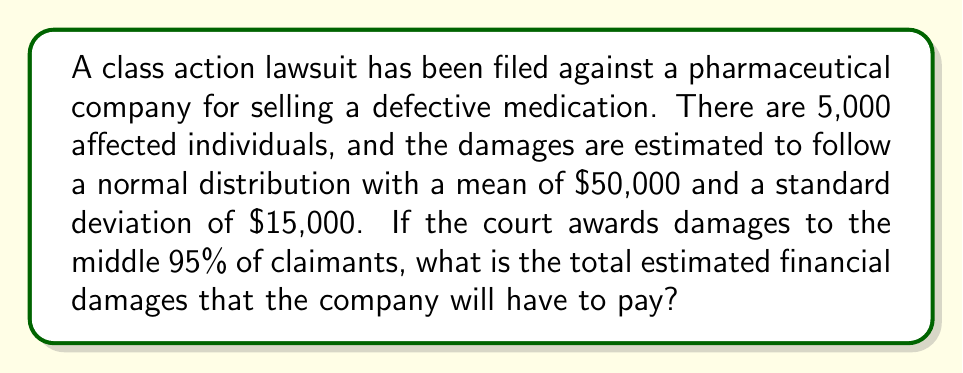Show me your answer to this math problem. To solve this problem, we'll follow these steps:

1. Identify the relevant statistical concepts:
   - Normal distribution
   - Z-score
   - Confidence interval

2. Find the z-scores for the middle 95% of the distribution:
   The middle 95% corresponds to a 95% confidence interval, which has z-scores of ±1.96.

3. Calculate the lower and upper bounds of the awards:
   Lower bound: $\mu - 1.96\sigma = 50000 - 1.96(15000) = 20600$
   Upper bound: $\mu + 1.96\sigma = 50000 + 1.96(15000) = 79400$

4. Calculate the number of claimants within this range:
   95% of 5,000 = 0.95 * 5000 = 4,750 claimants

5. Calculate the total damages:
   Total damages = Number of claimants * Average award
   Average award = $(\text{Lower bound} + \text{Upper bound}) / 2$
   
   $$\text{Average award} = \frac{20600 + 79400}{2} = 50000$$
   
   $$\text{Total damages} = 4750 * 50000 = 237,500,000$$

Therefore, the total estimated financial damages are $237,500,000.
Answer: $237,500,000 